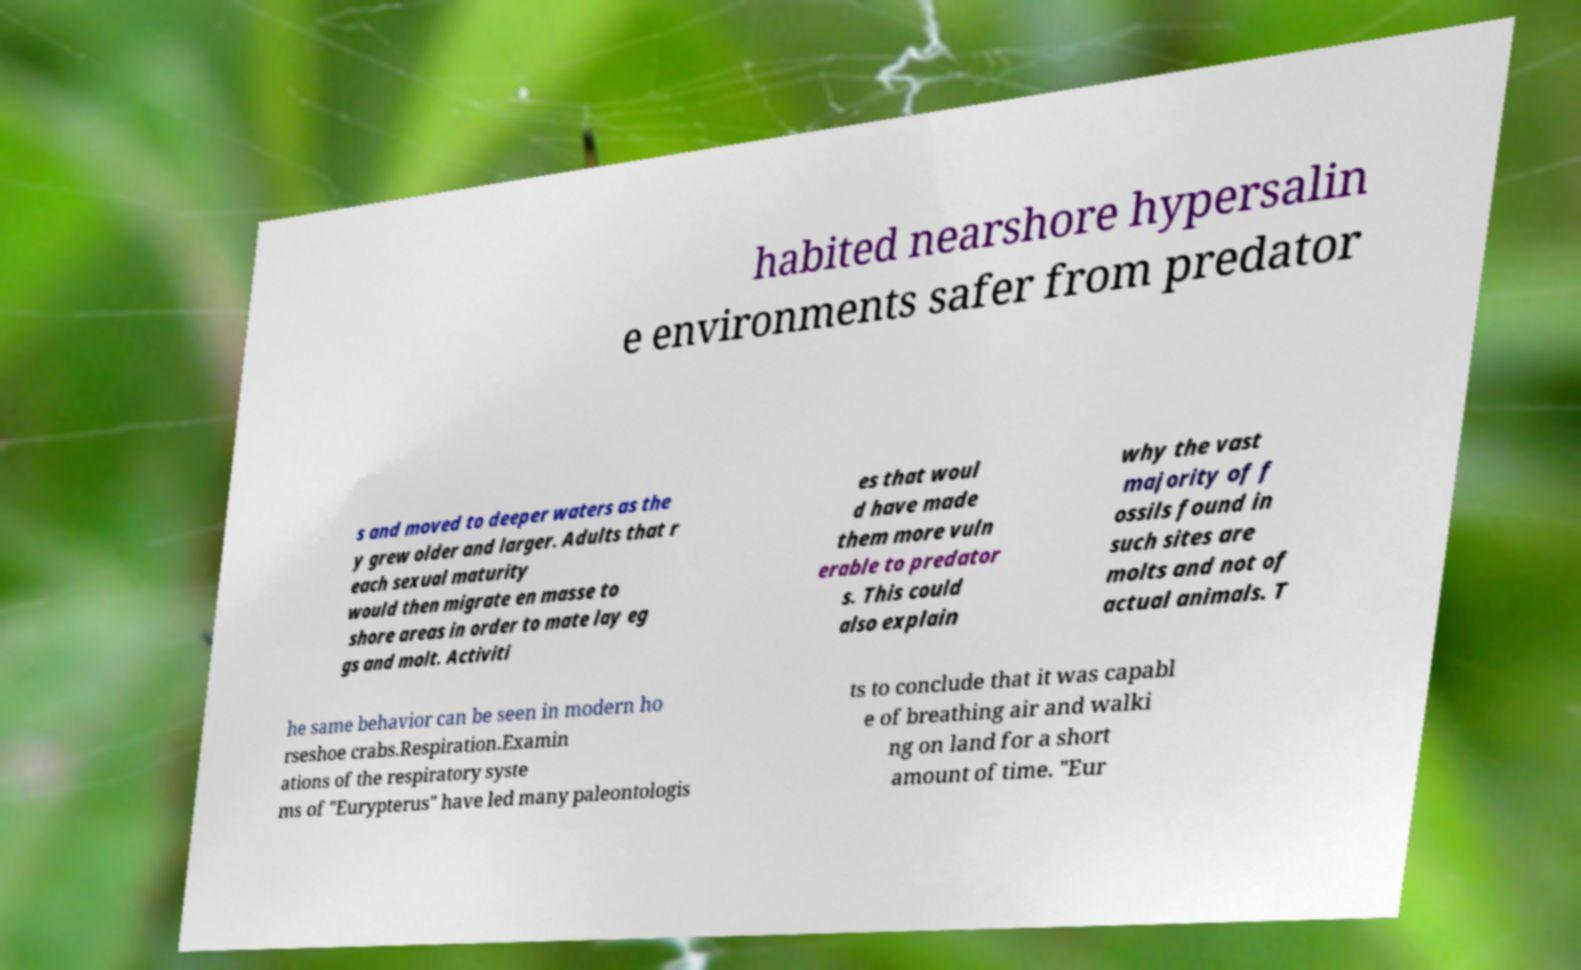Please identify and transcribe the text found in this image. habited nearshore hypersalin e environments safer from predator s and moved to deeper waters as the y grew older and larger. Adults that r each sexual maturity would then migrate en masse to shore areas in order to mate lay eg gs and molt. Activiti es that woul d have made them more vuln erable to predator s. This could also explain why the vast majority of f ossils found in such sites are molts and not of actual animals. T he same behavior can be seen in modern ho rseshoe crabs.Respiration.Examin ations of the respiratory syste ms of "Eurypterus" have led many paleontologis ts to conclude that it was capabl e of breathing air and walki ng on land for a short amount of time. "Eur 